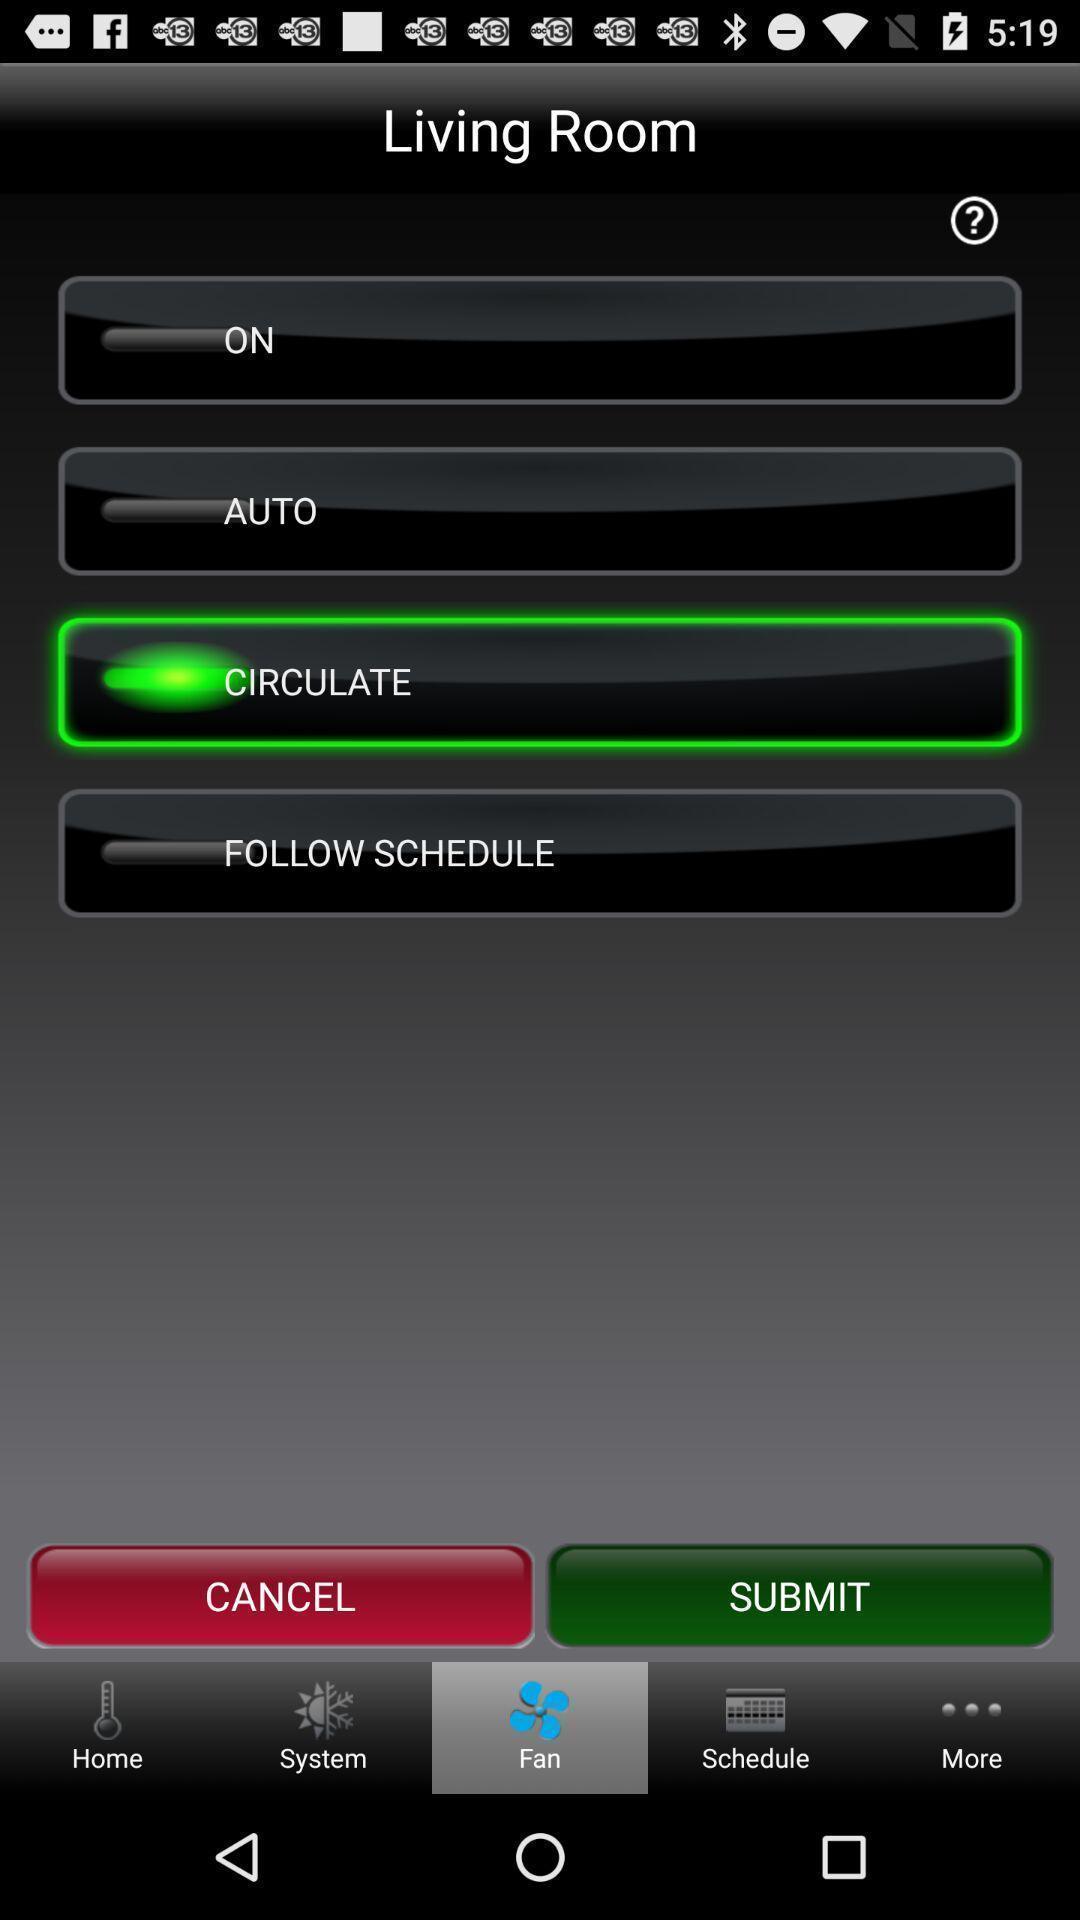Describe the key features of this screenshot. Screen display shows of a connect comfort app. 